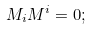<formula> <loc_0><loc_0><loc_500><loc_500>M _ { i } M ^ { i } = 0 ;</formula> 